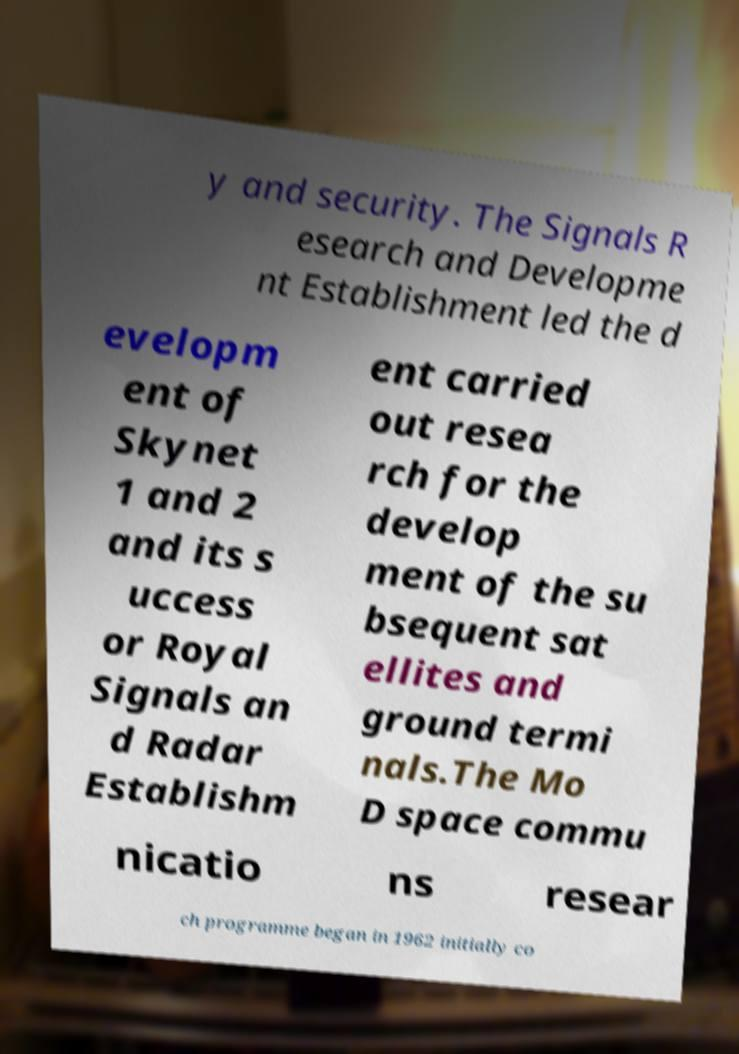What messages or text are displayed in this image? I need them in a readable, typed format. y and security. The Signals R esearch and Developme nt Establishment led the d evelopm ent of Skynet 1 and 2 and its s uccess or Royal Signals an d Radar Establishm ent carried out resea rch for the develop ment of the su bsequent sat ellites and ground termi nals.The Mo D space commu nicatio ns resear ch programme began in 1962 initially co 